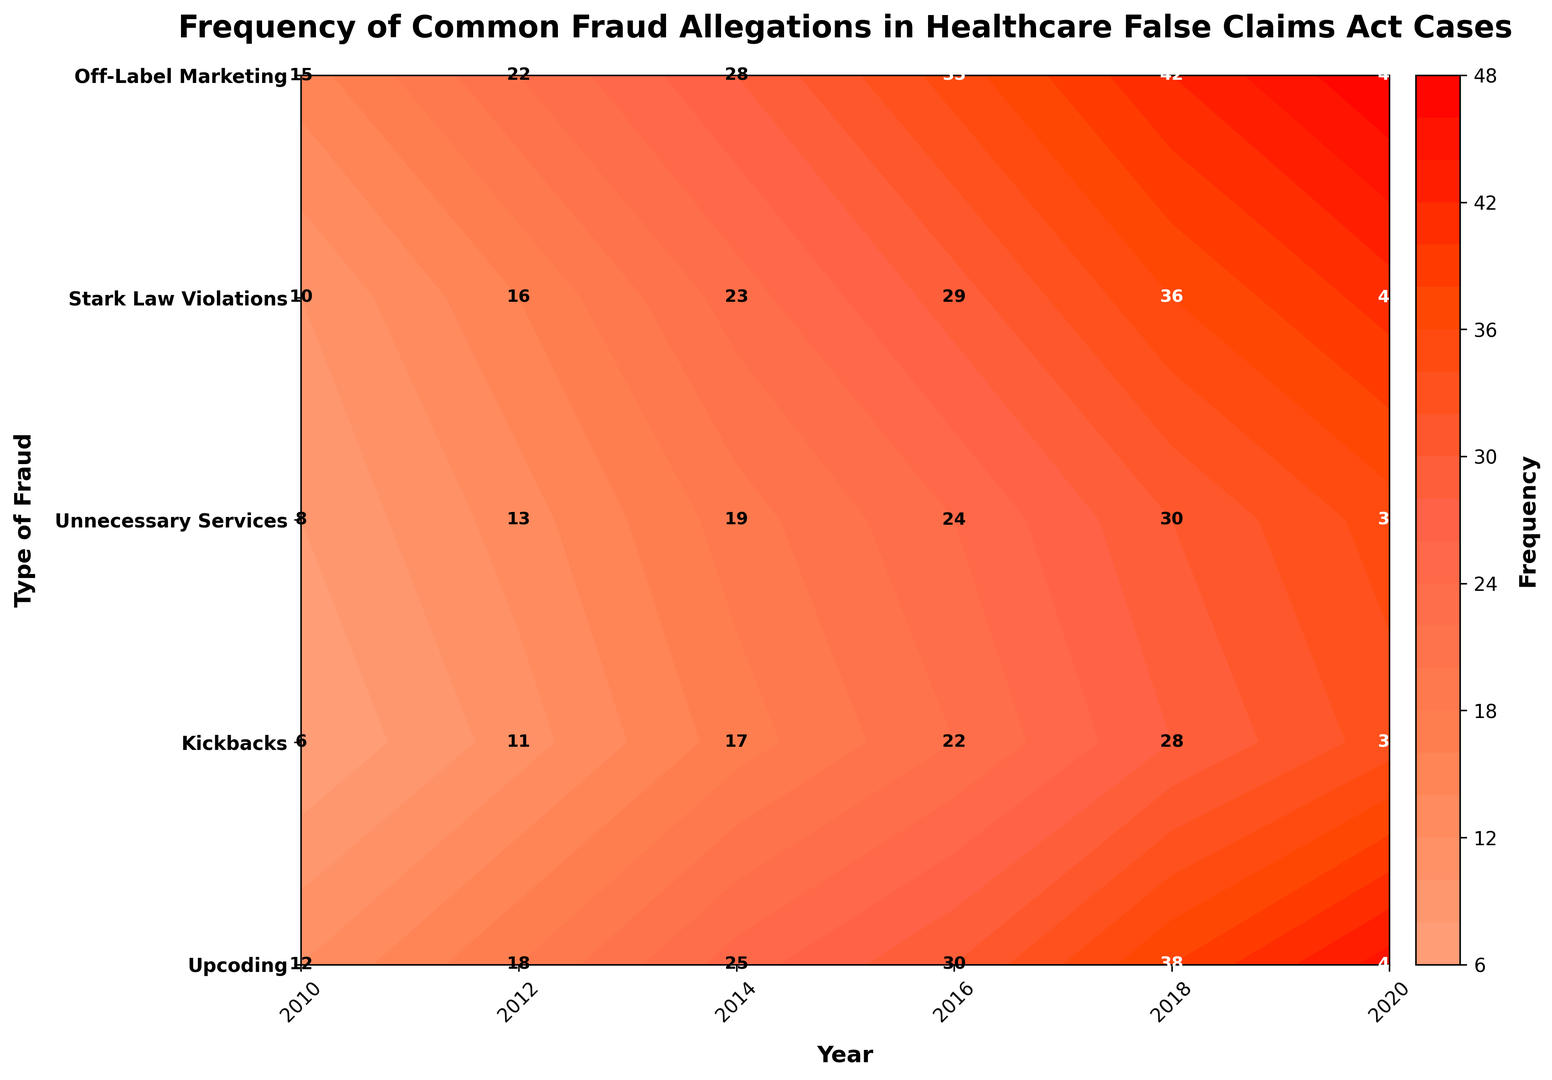What type of fraud had the highest frequency in 2016? The figure shows the frequency of different fraud types over various years. The darkest region in 2016 corresponds to "Upcoding" with a frequency of 35.
Answer: Upcoding Which year shows the least frequency of "Stark Law Violations"? In the figure, the lightest color corresponding to "Stark Law Violations" is in the year 2010 with a frequency of 8.
Answer: 2010 How many total fraud allegations were reported for "Unnecessary Services" from 2012 to 2020? According to the plot, the frequencies for "Unnecessary Services" are 16 in 2012, 23 in 2014, 29 in 2016, 36 in 2018, and 41 in 2020. Adding these values: 16 + 23 + 29 + 36 + 41 = 145.
Answer: 145 Which fraud type saw the greatest increase in frequency between 2010 and 2020? Comparing the beginning and ending frequencies, "Off-Label Marketing" increased from 6 in 2010 to 33 in 2020, making it the greatest increase (33 - 6 = 27).
Answer: Off-Label Marketing Compare the trend of "Kickbacks" with "Upcoding" from 2010 to 2020. Which fraud type had a higher frequency in 2018? The plot shows that in 2018, "Upcoding" has a frequency of 42 while "Kickbacks" has 38. Hence, "Upcoding" had a higher frequency.
Answer: Upcoding What is the average frequency of "Upcoding" allegations across all the years presented? According to the graph, the frequencies of "Upcoding" are 15, 22, 28, 35, 42, and 48. Averaging these values: (15 + 22 + 28 + 35 + 42 + 48) / 6 = 31.67 (rounded to two decimal places).
Answer: 31.67 Is there any fraud type with a distinctively lower frequency in all years compared to "Upcoding"? Observing the patterns, "Off-Label Marketing" consistently shows lower frequencies in comparison to "Upcoding" across all years.
Answer: Off-Label Marketing Which fraud type shows a consistent upward trend without any decrease in frequency between consecutive years? By examining the lines representing each type of fraud, "Kickbacks" shows a consistent upward trend from 2010 (12) to 2020 (45) without any decrease.
Answer: Kickbacks How does the frequency of "Kickbacks" in 2020 compare to the combined frequency of "Off-Label Marketing" and "Stark Law Violations" in 2014? In 2014, "Off-Label Marketing" is at 17 and "Stark Law Violations" at 19. Their combined frequency is 17 + 19 = 36, which is less than the 45 frequency of "Kickbacks" in 2020.
Answer: Kickbacks is higher 